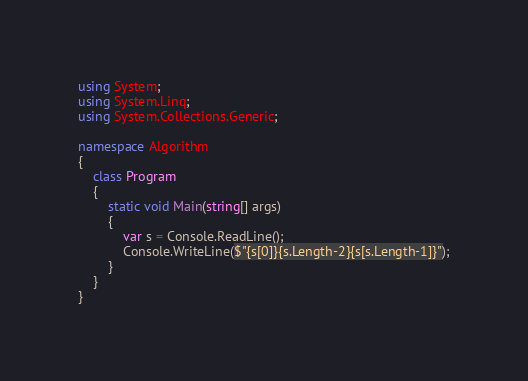<code> <loc_0><loc_0><loc_500><loc_500><_C#_>using System;
using System.Linq;
using System.Collections.Generic;

namespace Algorithm
{
    class Program
    {
        static void Main(string[] args)
        {
            var s = Console.ReadLine();
            Console.WriteLine($"{s[0]}{s.Length-2}{s[s.Length-1]}");
        }
    }
}
</code> 